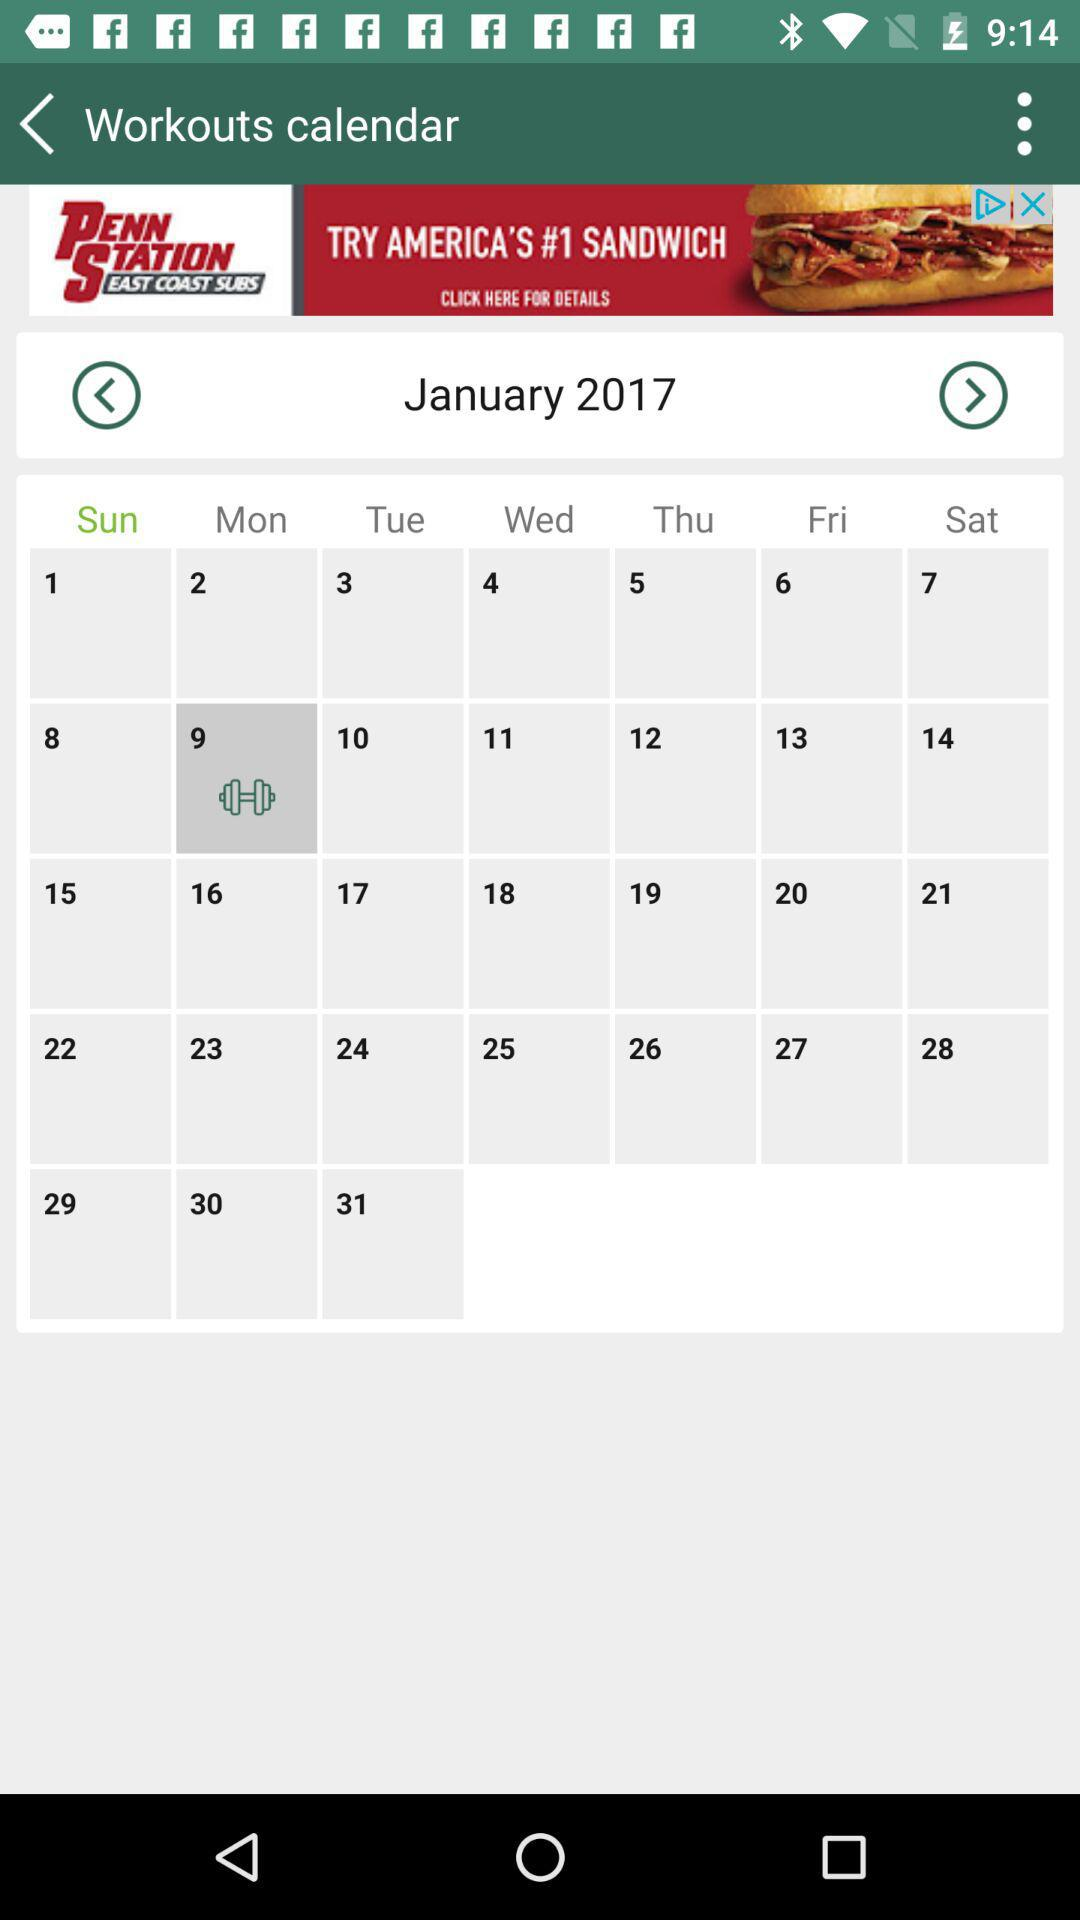On your workout date, what day is it? The day is Monday. 